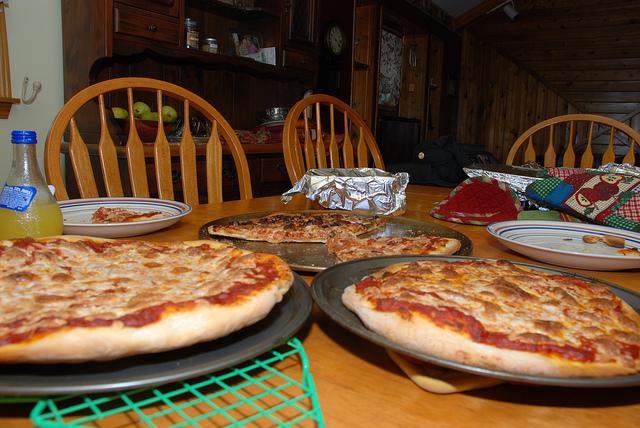Is this a restaurant?
Give a very brief answer. No. How many pizza that has not been eaten?
Be succinct. 2. What is the main food on the table?
Give a very brief answer. Pizza. 